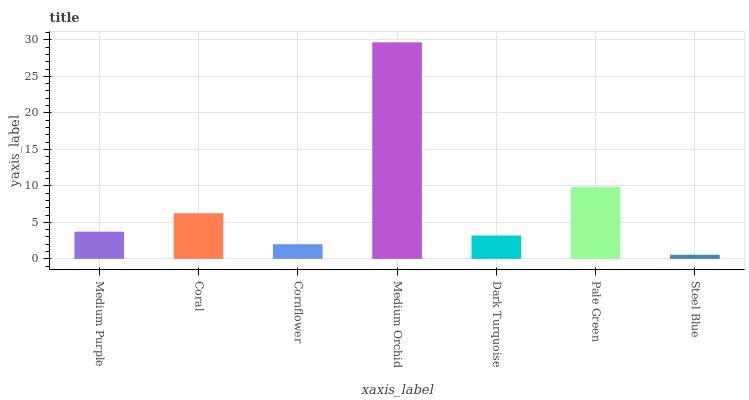Is Steel Blue the minimum?
Answer yes or no. Yes. Is Medium Orchid the maximum?
Answer yes or no. Yes. Is Coral the minimum?
Answer yes or no. No. Is Coral the maximum?
Answer yes or no. No. Is Coral greater than Medium Purple?
Answer yes or no. Yes. Is Medium Purple less than Coral?
Answer yes or no. Yes. Is Medium Purple greater than Coral?
Answer yes or no. No. Is Coral less than Medium Purple?
Answer yes or no. No. Is Medium Purple the high median?
Answer yes or no. Yes. Is Medium Purple the low median?
Answer yes or no. Yes. Is Dark Turquoise the high median?
Answer yes or no. No. Is Dark Turquoise the low median?
Answer yes or no. No. 